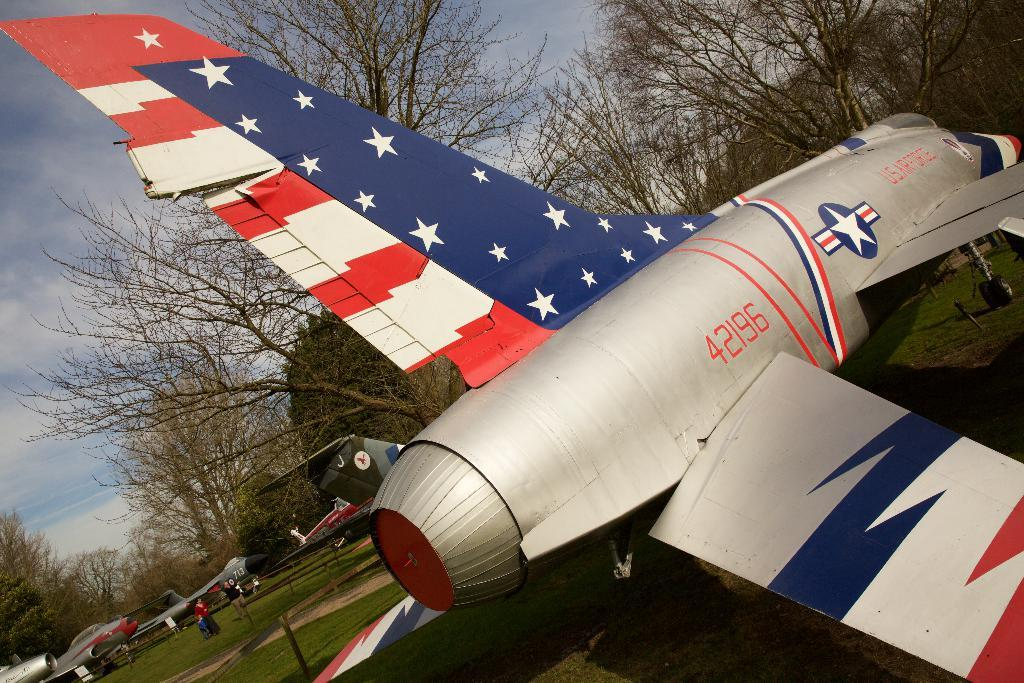<image>
Summarize the visual content of the image. A plane with stars and stripes with the number 42196 printed on it. 